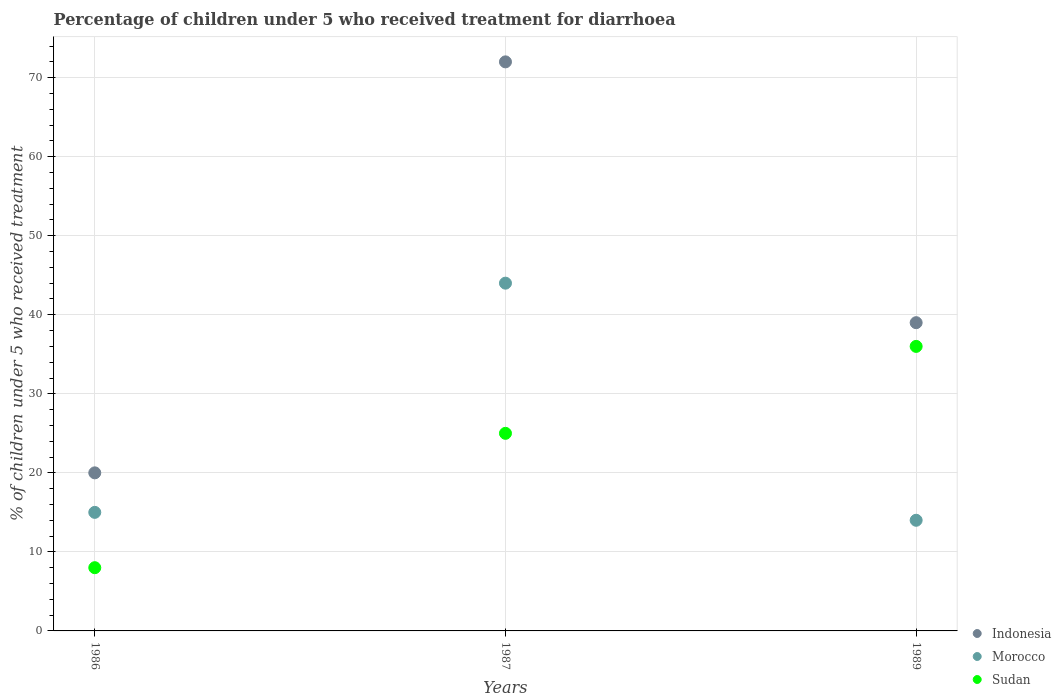Is the number of dotlines equal to the number of legend labels?
Ensure brevity in your answer.  Yes. What is the percentage of children who received treatment for diarrhoea  in Morocco in 1987?
Provide a short and direct response. 44. In which year was the percentage of children who received treatment for diarrhoea  in Morocco maximum?
Your response must be concise. 1987. In which year was the percentage of children who received treatment for diarrhoea  in Morocco minimum?
Give a very brief answer. 1989. What is the total percentage of children who received treatment for diarrhoea  in Indonesia in the graph?
Make the answer very short. 131. What is the difference between the percentage of children who received treatment for diarrhoea  in Indonesia in 1986 and that in 1989?
Your answer should be very brief. -19. What is the difference between the percentage of children who received treatment for diarrhoea  in Sudan in 1989 and the percentage of children who received treatment for diarrhoea  in Indonesia in 1987?
Make the answer very short. -36. What is the average percentage of children who received treatment for diarrhoea  in Indonesia per year?
Your answer should be compact. 43.67. In how many years, is the percentage of children who received treatment for diarrhoea  in Indonesia greater than 34 %?
Offer a very short reply. 2. What is the ratio of the percentage of children who received treatment for diarrhoea  in Morocco in 1986 to that in 1987?
Ensure brevity in your answer.  0.34. Is the percentage of children who received treatment for diarrhoea  in Indonesia in 1987 less than that in 1989?
Provide a succinct answer. No. What is the difference between the highest and the second highest percentage of children who received treatment for diarrhoea  in Indonesia?
Offer a very short reply. 33. Is it the case that in every year, the sum of the percentage of children who received treatment for diarrhoea  in Sudan and percentage of children who received treatment for diarrhoea  in Morocco  is greater than the percentage of children who received treatment for diarrhoea  in Indonesia?
Provide a succinct answer. No. Is the percentage of children who received treatment for diarrhoea  in Sudan strictly greater than the percentage of children who received treatment for diarrhoea  in Morocco over the years?
Give a very brief answer. No. Is the percentage of children who received treatment for diarrhoea  in Indonesia strictly less than the percentage of children who received treatment for diarrhoea  in Sudan over the years?
Offer a very short reply. No. How many years are there in the graph?
Offer a very short reply. 3. What is the difference between two consecutive major ticks on the Y-axis?
Offer a terse response. 10. Are the values on the major ticks of Y-axis written in scientific E-notation?
Offer a very short reply. No. Does the graph contain grids?
Give a very brief answer. Yes. Where does the legend appear in the graph?
Offer a terse response. Bottom right. How are the legend labels stacked?
Make the answer very short. Vertical. What is the title of the graph?
Your answer should be compact. Percentage of children under 5 who received treatment for diarrhoea. Does "Dominica" appear as one of the legend labels in the graph?
Offer a very short reply. No. What is the label or title of the Y-axis?
Keep it short and to the point. % of children under 5 who received treatment. What is the % of children under 5 who received treatment in Morocco in 1986?
Your response must be concise. 15. What is the % of children under 5 who received treatment in Morocco in 1987?
Your response must be concise. 44. What is the % of children under 5 who received treatment in Morocco in 1989?
Offer a terse response. 14. What is the % of children under 5 who received treatment in Sudan in 1989?
Keep it short and to the point. 36. What is the total % of children under 5 who received treatment in Indonesia in the graph?
Offer a very short reply. 131. What is the total % of children under 5 who received treatment of Morocco in the graph?
Give a very brief answer. 73. What is the difference between the % of children under 5 who received treatment of Indonesia in 1986 and that in 1987?
Provide a short and direct response. -52. What is the difference between the % of children under 5 who received treatment of Indonesia in 1986 and that in 1989?
Make the answer very short. -19. What is the difference between the % of children under 5 who received treatment of Sudan in 1986 and that in 1989?
Your answer should be very brief. -28. What is the difference between the % of children under 5 who received treatment in Indonesia in 1986 and the % of children under 5 who received treatment in Morocco in 1987?
Provide a succinct answer. -24. What is the difference between the % of children under 5 who received treatment of Indonesia in 1987 and the % of children under 5 who received treatment of Sudan in 1989?
Offer a terse response. 36. What is the difference between the % of children under 5 who received treatment in Morocco in 1987 and the % of children under 5 who received treatment in Sudan in 1989?
Offer a terse response. 8. What is the average % of children under 5 who received treatment of Indonesia per year?
Your answer should be very brief. 43.67. What is the average % of children under 5 who received treatment of Morocco per year?
Provide a short and direct response. 24.33. In the year 1986, what is the difference between the % of children under 5 who received treatment in Indonesia and % of children under 5 who received treatment in Morocco?
Keep it short and to the point. 5. In the year 1986, what is the difference between the % of children under 5 who received treatment in Indonesia and % of children under 5 who received treatment in Sudan?
Ensure brevity in your answer.  12. In the year 1987, what is the difference between the % of children under 5 who received treatment of Indonesia and % of children under 5 who received treatment of Morocco?
Your answer should be very brief. 28. In the year 1987, what is the difference between the % of children under 5 who received treatment in Indonesia and % of children under 5 who received treatment in Sudan?
Your answer should be very brief. 47. In the year 1989, what is the difference between the % of children under 5 who received treatment in Indonesia and % of children under 5 who received treatment in Morocco?
Provide a succinct answer. 25. In the year 1989, what is the difference between the % of children under 5 who received treatment in Indonesia and % of children under 5 who received treatment in Sudan?
Your answer should be compact. 3. What is the ratio of the % of children under 5 who received treatment of Indonesia in 1986 to that in 1987?
Keep it short and to the point. 0.28. What is the ratio of the % of children under 5 who received treatment of Morocco in 1986 to that in 1987?
Make the answer very short. 0.34. What is the ratio of the % of children under 5 who received treatment in Sudan in 1986 to that in 1987?
Keep it short and to the point. 0.32. What is the ratio of the % of children under 5 who received treatment in Indonesia in 1986 to that in 1989?
Your answer should be very brief. 0.51. What is the ratio of the % of children under 5 who received treatment of Morocco in 1986 to that in 1989?
Ensure brevity in your answer.  1.07. What is the ratio of the % of children under 5 who received treatment in Sudan in 1986 to that in 1989?
Give a very brief answer. 0.22. What is the ratio of the % of children under 5 who received treatment in Indonesia in 1987 to that in 1989?
Give a very brief answer. 1.85. What is the ratio of the % of children under 5 who received treatment in Morocco in 1987 to that in 1989?
Make the answer very short. 3.14. What is the ratio of the % of children under 5 who received treatment in Sudan in 1987 to that in 1989?
Offer a terse response. 0.69. What is the difference between the highest and the second highest % of children under 5 who received treatment of Indonesia?
Offer a very short reply. 33. What is the difference between the highest and the lowest % of children under 5 who received treatment of Indonesia?
Provide a succinct answer. 52. What is the difference between the highest and the lowest % of children under 5 who received treatment in Morocco?
Your answer should be compact. 30. 